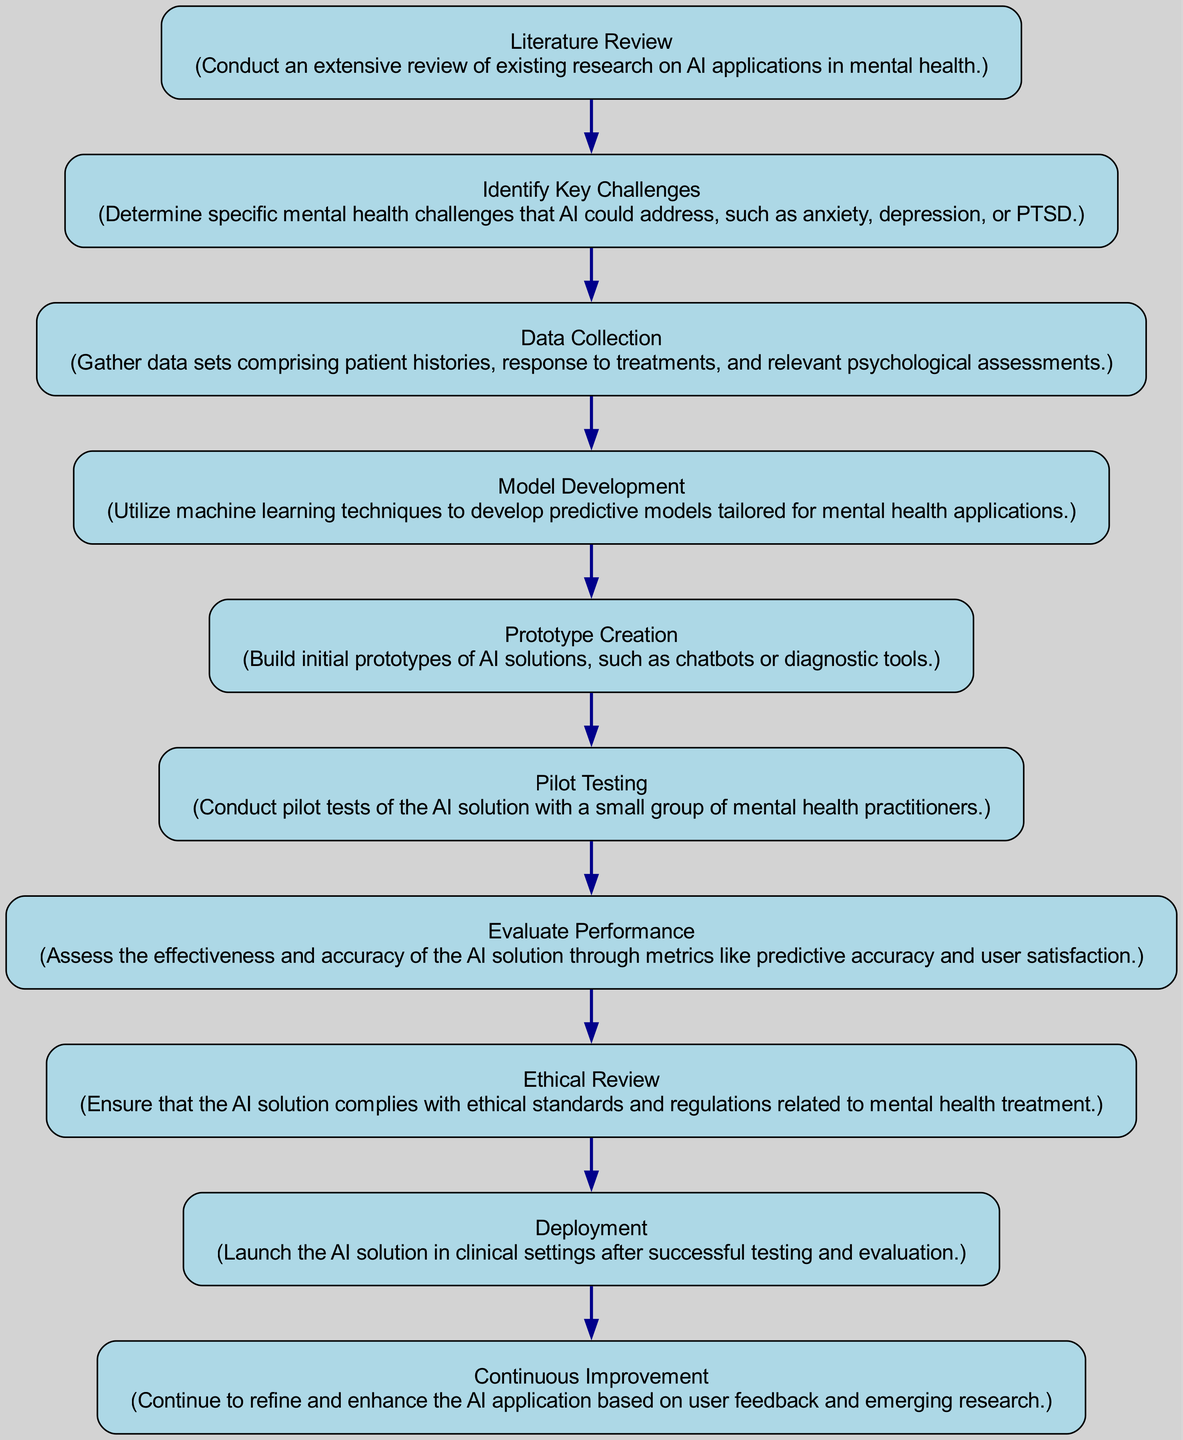What is the first step in the research process? The first step in the process is indicated as "Literature Review." It is the starting point and is positioned at the top of the directed graph, showing the flow of the research process.
Answer: Literature Review How many nodes are present in the diagram? To find the number of nodes, we count each distinct element represented in the data. There are 10 unique nodes listed in the 'nodes' section of the diagram data.
Answer: 10 What is the last step before deployment? The step immediately prior to "Deployment" is "Ethical Review." This step ensures the compliance of the AI solution with ethical standards before it is launched.
Answer: Ethical Review Which step follows data collection? According to the directed edges, the step following "Data Collection" is "Model Development." The edge connects these two nodes in the progression of the research process.
Answer: Model Development What does the 'Pilot Testing' phase lead to? The directed edge shows that "Pilot Testing" leads to "Evaluate Performance." This indicates that after pilot tests are conducted, the next action is to assess the AI solution's effectiveness.
Answer: Evaluate Performance How many edges are there linking the nodes? The number of edges can be determined by counting the connections between nodes in the 'edges' section. There are 9 edges described in the provided data.
Answer: 9 Which two nodes are connected by an edge to indicate ethical considerations? The nodes connected by an edge that involve ethical considerations are "Evaluate Performance" and "Ethical Review." The edge signifies that evaluation leads to a review of ethical standards.
Answer: Evaluate Performance and Ethical Review What is the flow direction from "Prototype Creation"? The flow direction from "Prototype Creation" proceeds to "Pilot Testing," as evidenced by the directed edge connecting these two nodes. This establishes the order in the research process.
Answer: Pilot Testing What phase comes after "Deployment"? Following "Deployment," the next phase is "Continuous Improvement," indicating that the process continues even after the AI solution is launched in clinical settings.
Answer: Continuous Improvement 